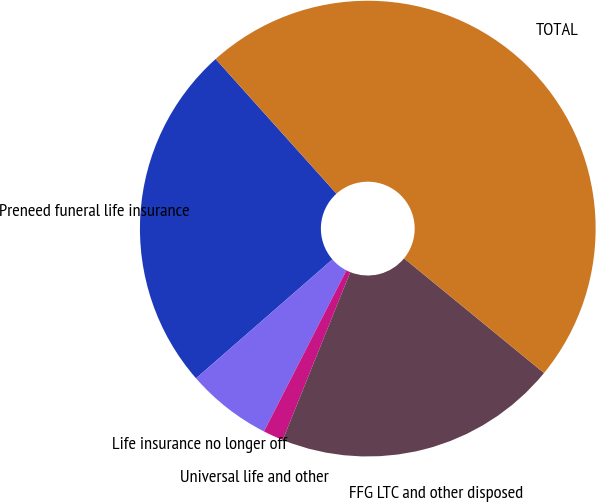Convert chart. <chart><loc_0><loc_0><loc_500><loc_500><pie_chart><fcel>Preneed funeral life insurance<fcel>Life insurance no longer off<fcel>Universal life and other<fcel>FFG LTC and other disposed<fcel>TOTAL<nl><fcel>24.77%<fcel>6.06%<fcel>1.44%<fcel>20.16%<fcel>47.56%<nl></chart> 